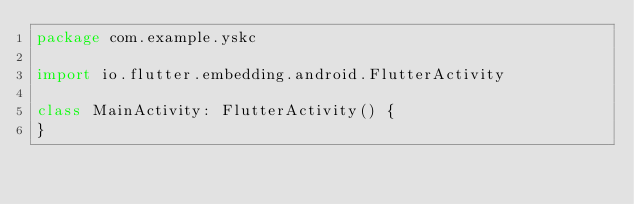Convert code to text. <code><loc_0><loc_0><loc_500><loc_500><_Kotlin_>package com.example.yskc

import io.flutter.embedding.android.FlutterActivity

class MainActivity: FlutterActivity() {
}
</code> 